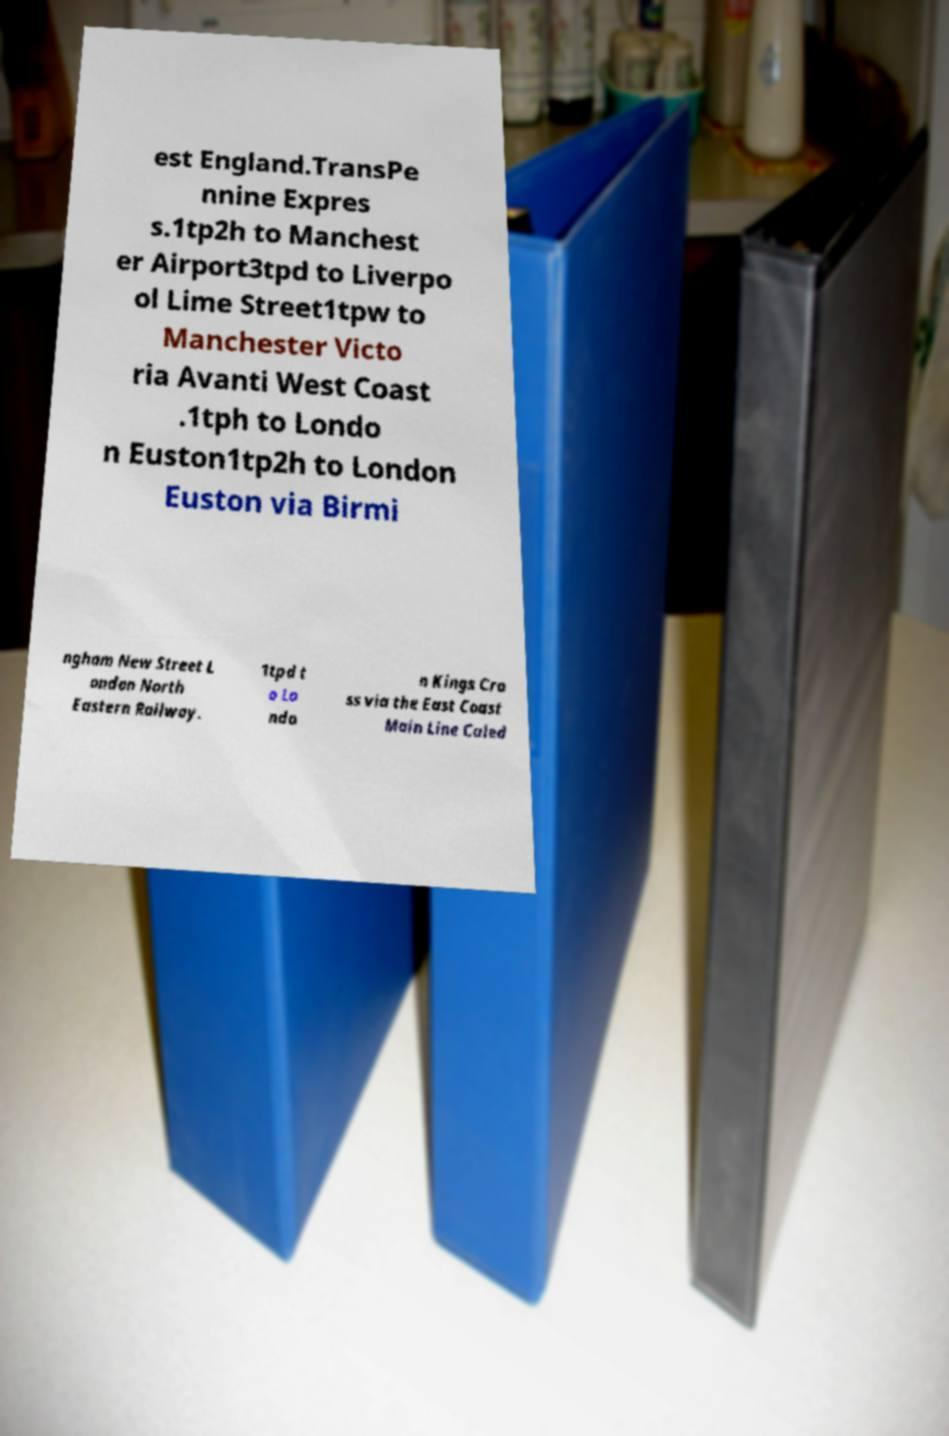Can you read and provide the text displayed in the image?This photo seems to have some interesting text. Can you extract and type it out for me? est England.TransPe nnine Expres s.1tp2h to Manchest er Airport3tpd to Liverpo ol Lime Street1tpw to Manchester Victo ria Avanti West Coast .1tph to Londo n Euston1tp2h to London Euston via Birmi ngham New Street L ondon North Eastern Railway. 1tpd t o Lo ndo n Kings Cro ss via the East Coast Main Line Caled 